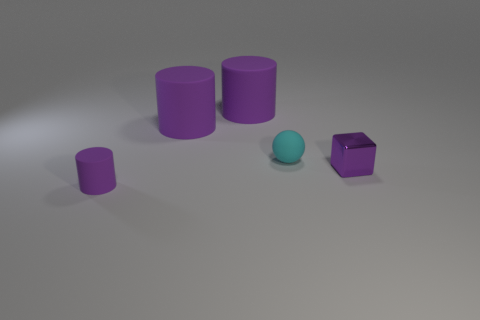There is a small object that is the same color as the small cylinder; what is it made of?
Offer a terse response. Metal. Is there a cyan thing left of the small purple object that is in front of the object on the right side of the small sphere?
Offer a very short reply. No. Do the cylinder that is in front of the tiny purple shiny object and the small purple object that is behind the small purple rubber object have the same material?
Offer a terse response. No. What number of things are cylinders or rubber cylinders that are behind the tiny ball?
Your answer should be very brief. 3. How many other cyan things are the same shape as the metal object?
Your response must be concise. 0. There is a purple cylinder that is the same size as the purple block; what is it made of?
Ensure brevity in your answer.  Rubber. There is a purple object that is in front of the tiny purple thing to the right of the tiny matte object that is behind the small purple cylinder; what is its size?
Your response must be concise. Small. Do the tiny rubber object that is on the right side of the tiny purple rubber thing and the rubber object in front of the small cyan ball have the same color?
Your response must be concise. No. How many cyan objects are small rubber spheres or metallic things?
Your answer should be compact. 1. How many cyan metal cylinders have the same size as the metal thing?
Your answer should be very brief. 0. 